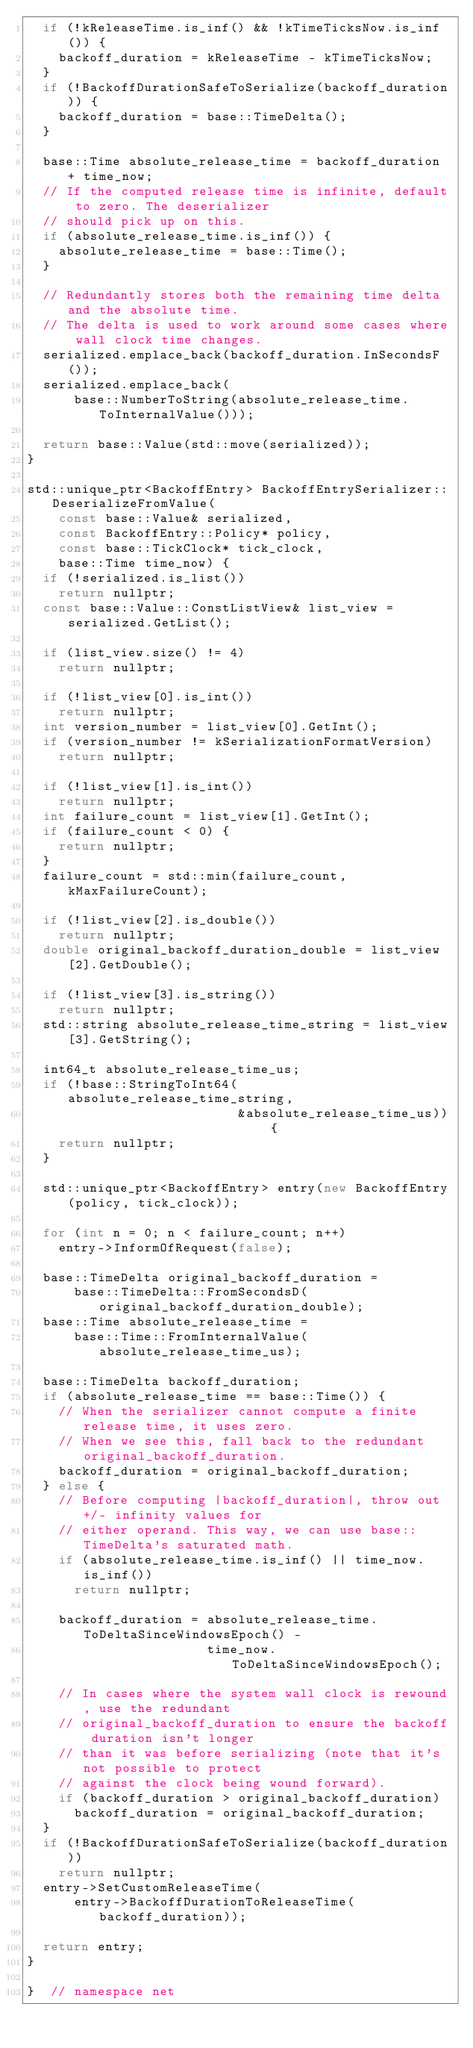Convert code to text. <code><loc_0><loc_0><loc_500><loc_500><_C++_>  if (!kReleaseTime.is_inf() && !kTimeTicksNow.is_inf()) {
    backoff_duration = kReleaseTime - kTimeTicksNow;
  }
  if (!BackoffDurationSafeToSerialize(backoff_duration)) {
    backoff_duration = base::TimeDelta();
  }

  base::Time absolute_release_time = backoff_duration + time_now;
  // If the computed release time is infinite, default to zero. The deserializer
  // should pick up on this.
  if (absolute_release_time.is_inf()) {
    absolute_release_time = base::Time();
  }

  // Redundantly stores both the remaining time delta and the absolute time.
  // The delta is used to work around some cases where wall clock time changes.
  serialized.emplace_back(backoff_duration.InSecondsF());
  serialized.emplace_back(
      base::NumberToString(absolute_release_time.ToInternalValue()));

  return base::Value(std::move(serialized));
}

std::unique_ptr<BackoffEntry> BackoffEntrySerializer::DeserializeFromValue(
    const base::Value& serialized,
    const BackoffEntry::Policy* policy,
    const base::TickClock* tick_clock,
    base::Time time_now) {
  if (!serialized.is_list())
    return nullptr;
  const base::Value::ConstListView& list_view = serialized.GetList();

  if (list_view.size() != 4)
    return nullptr;

  if (!list_view[0].is_int())
    return nullptr;
  int version_number = list_view[0].GetInt();
  if (version_number != kSerializationFormatVersion)
    return nullptr;

  if (!list_view[1].is_int())
    return nullptr;
  int failure_count = list_view[1].GetInt();
  if (failure_count < 0) {
    return nullptr;
  }
  failure_count = std::min(failure_count, kMaxFailureCount);

  if (!list_view[2].is_double())
    return nullptr;
  double original_backoff_duration_double = list_view[2].GetDouble();

  if (!list_view[3].is_string())
    return nullptr;
  std::string absolute_release_time_string = list_view[3].GetString();

  int64_t absolute_release_time_us;
  if (!base::StringToInt64(absolute_release_time_string,
                           &absolute_release_time_us)) {
    return nullptr;
  }

  std::unique_ptr<BackoffEntry> entry(new BackoffEntry(policy, tick_clock));

  for (int n = 0; n < failure_count; n++)
    entry->InformOfRequest(false);

  base::TimeDelta original_backoff_duration =
      base::TimeDelta::FromSecondsD(original_backoff_duration_double);
  base::Time absolute_release_time =
      base::Time::FromInternalValue(absolute_release_time_us);

  base::TimeDelta backoff_duration;
  if (absolute_release_time == base::Time()) {
    // When the serializer cannot compute a finite release time, it uses zero.
    // When we see this, fall back to the redundant original_backoff_duration.
    backoff_duration = original_backoff_duration;
  } else {
    // Before computing |backoff_duration|, throw out +/- infinity values for
    // either operand. This way, we can use base::TimeDelta's saturated math.
    if (absolute_release_time.is_inf() || time_now.is_inf())
      return nullptr;

    backoff_duration = absolute_release_time.ToDeltaSinceWindowsEpoch() -
                       time_now.ToDeltaSinceWindowsEpoch();

    // In cases where the system wall clock is rewound, use the redundant
    // original_backoff_duration to ensure the backoff duration isn't longer
    // than it was before serializing (note that it's not possible to protect
    // against the clock being wound forward).
    if (backoff_duration > original_backoff_duration)
      backoff_duration = original_backoff_duration;
  }
  if (!BackoffDurationSafeToSerialize(backoff_duration))
    return nullptr;
  entry->SetCustomReleaseTime(
      entry->BackoffDurationToReleaseTime(backoff_duration));

  return entry;
}

}  // namespace net
</code> 